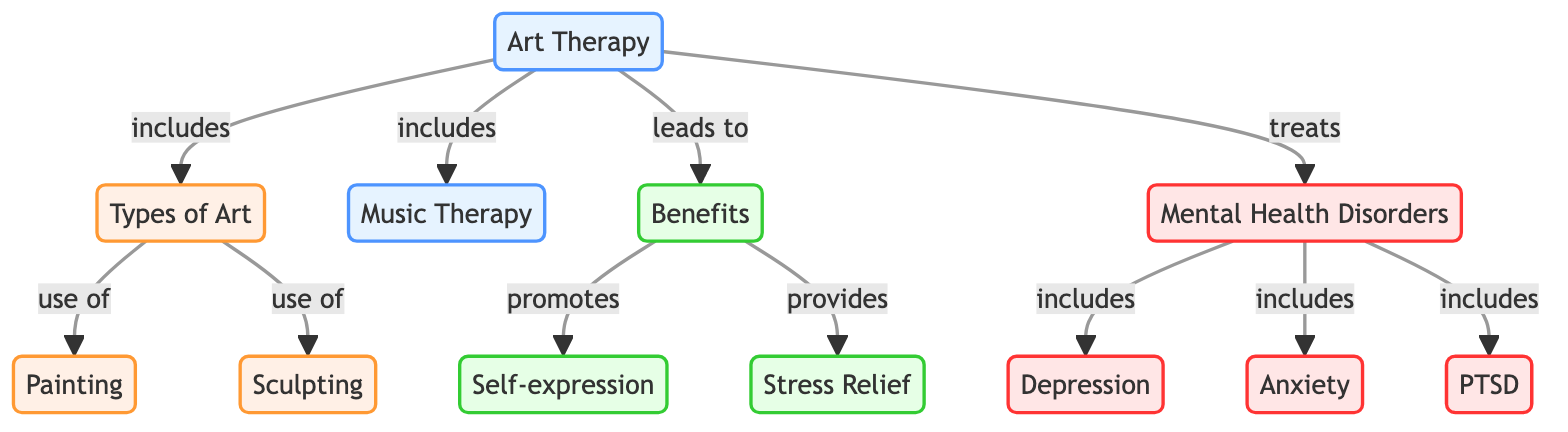What types of art are included in art therapy? The diagram specifies that art therapy includes types of art such as painting and sculpting. By examining the connections, we can see the direct links to these forms of artistic expression under the node for types of art.
Answer: painting, sculpting How many mental health disorders are mentioned in the diagram? The diagram lists three specific mental health disorders under the disorders node: depression, anxiety, and PTSD. Counting these connections allows us to determine the total.
Answer: 3 What benefits does art therapy provide? According to the diagram, art therapy leads to benefits such as self-expression and stress relief, which are explicitly mentioned as outcomes of the therapy. By tracing the connections from art therapy to benefits, we can identify these two specific benefits.
Answer: self-expression, stress relief Which type of therapy includes music? The diagram indicates that music therapy is included under the broader category of art therapy. By analyzing the connections, we can see that both art therapy and music therapy are part of therapeutic practices listed.
Answer: art therapy What are the relationships between art therapy and mental health disorders? The diagram illustrates that art therapy treats disorders, which include depression, anxiety, and PTSD. By following the connections from art therapy to disorders, we establish these relationships.
Answer: treats Which type of art is used for self-expression? According to the diagram, self-expression is one of the benefits of art therapy, which may involve the use of various art forms like painting and sculpting for expressing feelings. The benefits node connects back to the types of art used in therapy.
Answer: painting, sculpting 